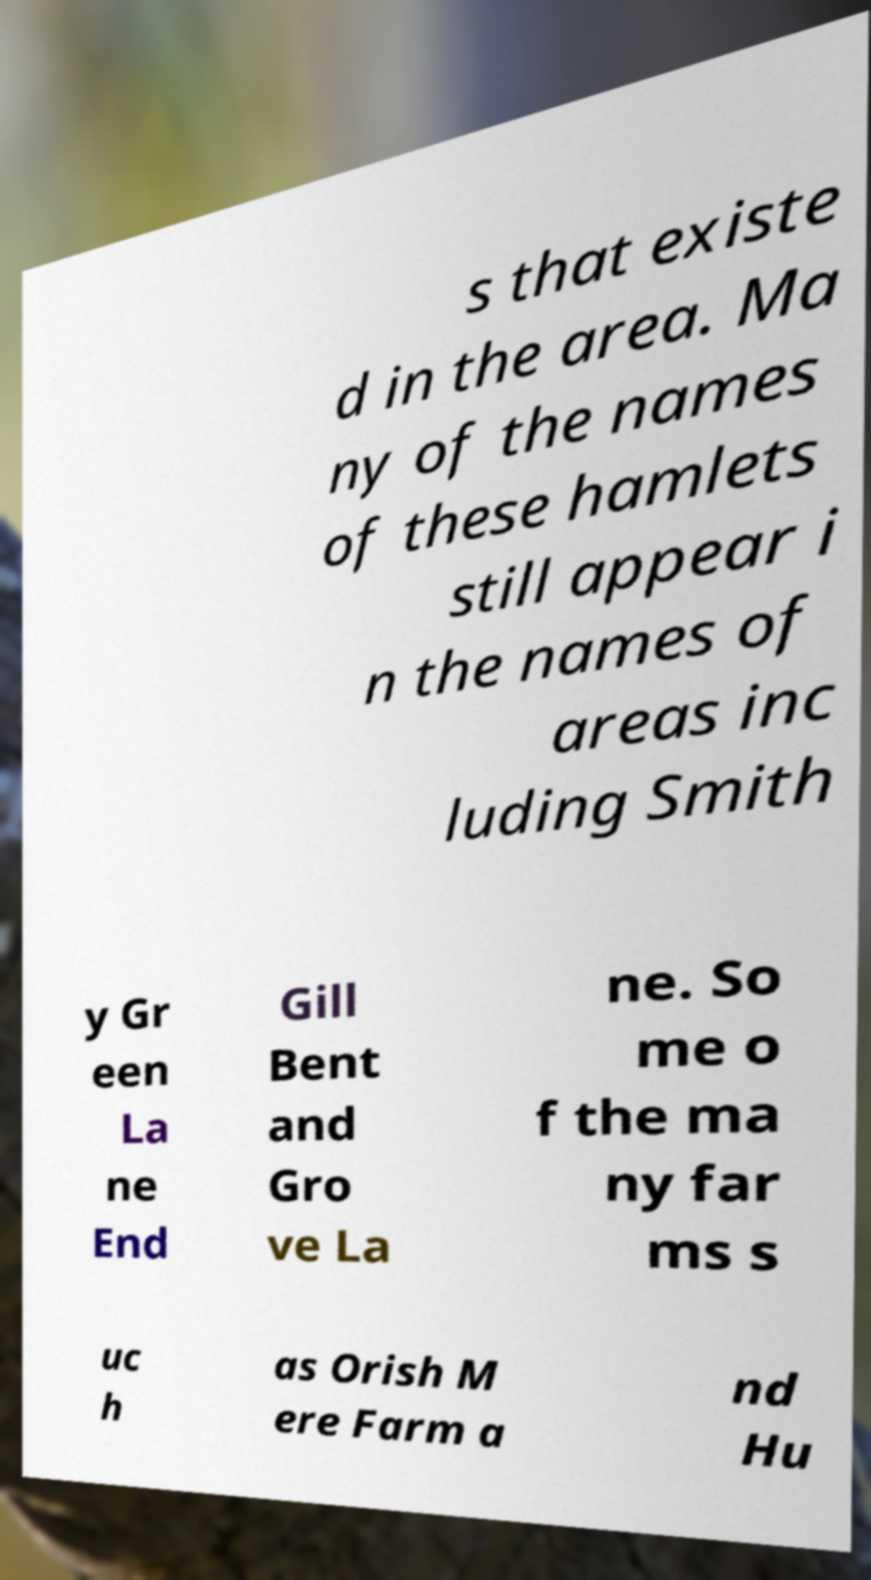Can you read and provide the text displayed in the image?This photo seems to have some interesting text. Can you extract and type it out for me? s that existe d in the area. Ma ny of the names of these hamlets still appear i n the names of areas inc luding Smith y Gr een La ne End Gill Bent and Gro ve La ne. So me o f the ma ny far ms s uc h as Orish M ere Farm a nd Hu 